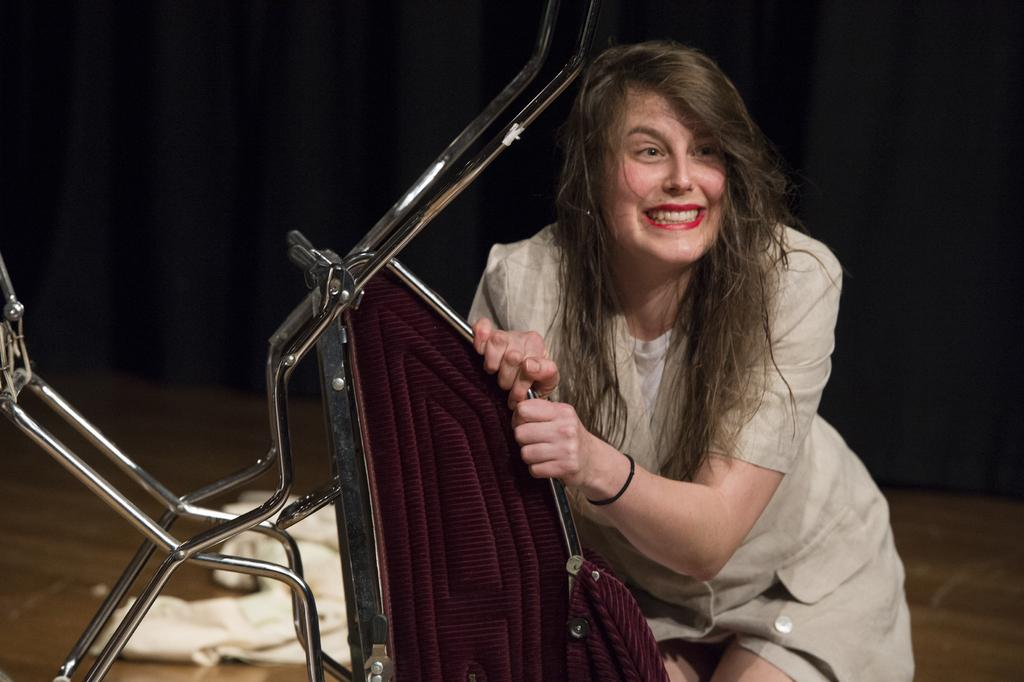What is the lady in the image doing? The lady is sitting on a chair in the image. What is the lady's facial expression? The lady is smiling. Is the lady holding anything in the image? Yes, the lady is holding the chair. What color is the lady's dress? The lady is wearing an ivory color dress. What can be seen in the background of the image? There is something black in the background of the image, which looks like a curtain. How many boys are visible in the image? There are no boys present in the image; it features a lady sitting on a chair. What type of parcel is being delivered in the image? There is no parcel being delivered in the image; the lady is sitting on a chair and holding it. 